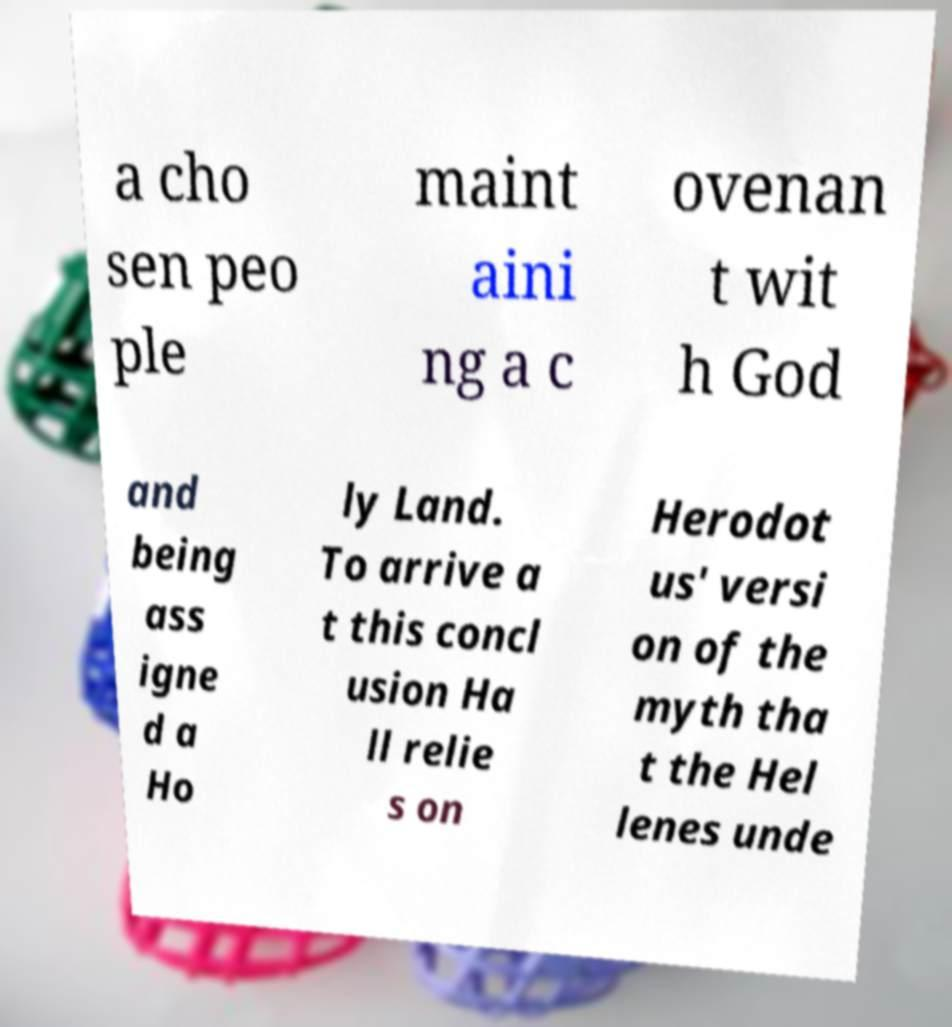Can you read and provide the text displayed in the image?This photo seems to have some interesting text. Can you extract and type it out for me? a cho sen peo ple maint aini ng a c ovenan t wit h God and being ass igne d a Ho ly Land. To arrive a t this concl usion Ha ll relie s on Herodot us' versi on of the myth tha t the Hel lenes unde 